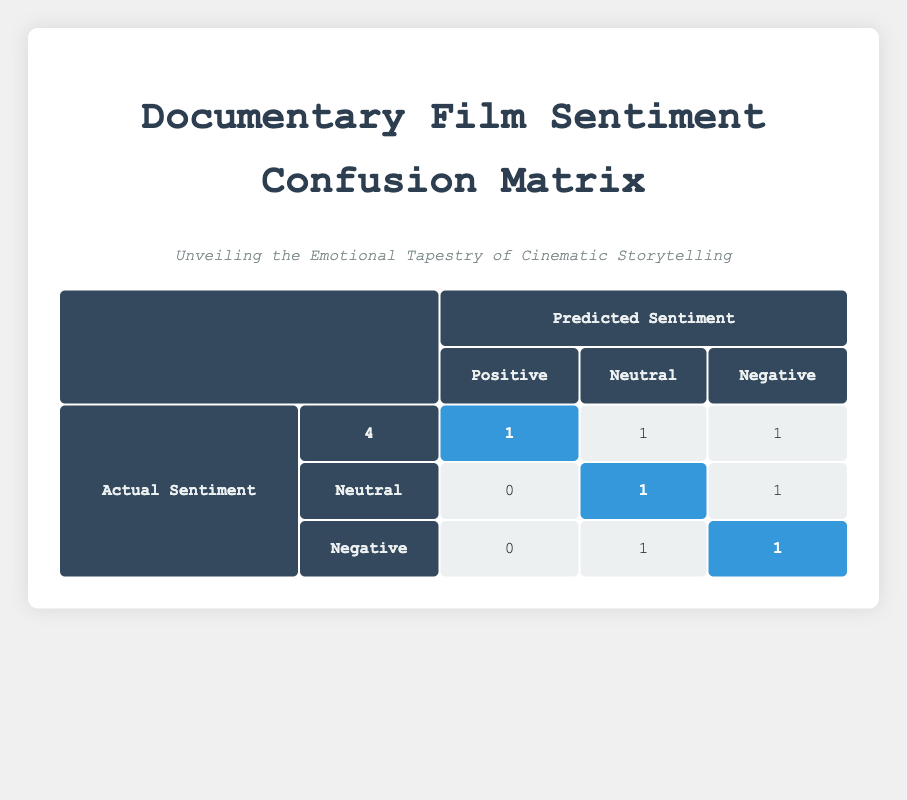What is the total number of films that had a predicted sentiment of Positive? By examining the table, we add up the values in the "Positive" column for all actual sentiments, which are 4 (Positive) + 0 (Neutral) + 0 (Negative) = 4 films with a predicted sentiment of Positive.
Answer: 4 How many films received a Neutral rating as their predicted sentiment? Looking at the table, we find that Neutral is predicted for 1 film where the actual sentiment is Positive and 1 film where the actual sentiment is Negative, making a total of 1 + 1 = 2 films.
Answer: 2 Did any films that had a Mixed actual sentiment also get predicted as Positive? In the table, no films with Mixed as actual sentiment are predicted as Positive, since the counts for Mixed actual sentiment show only 1 in the Negative column and 1 in the Neutral column. Therefore, the response is No.
Answer: No Which actual sentiment had the highest predicted sentiment of Negative? Evaluating the table, we see that for actual sentiment Negative, the count for Negative predicted is 1, and for Mixed, it is also 1. Since both counts are tied, we conclude that the highest predicted sentiment for Negative is 1 for both actual sentiments.
Answer: 1 What percentage of films with an actual sentiment of Positive had their predicted sentiment correctly identified? The number of films with actual sentiment Positive is 4 (correctly predicted) out of a total of 6 films in that category, leading to a calculation of (4 / 6) * 100 = 66.67%. Therefore, approximately 67% of the predictions were correct for Positive sentiments.
Answer: 67% How many films were incorrectly predicted as Negative when their actual sentiment was Positive? In the table, only 1 film under the Positive actual sentiment had its predicted sentiment as Negative, so the answer is simply the count of that prediction.
Answer: 1 Which actual sentiment had the least representation in terms of predicted sentiment? Checking the counts in the table, the Neutral actual sentiment has the lowest count overall, which is just 1, as it appears only once in the predicted sentiment table.
Answer: Neutral If we combine the films with Neutral and Negative predicted sentiments, what is the total? From the table, the Neutral predictions total 1 (from actual Positive) and the Negative total 3 (one from Neutral and one from Negative), combining these gives us 1 + 1 + 1 = 3 films overall.
Answer: 3 